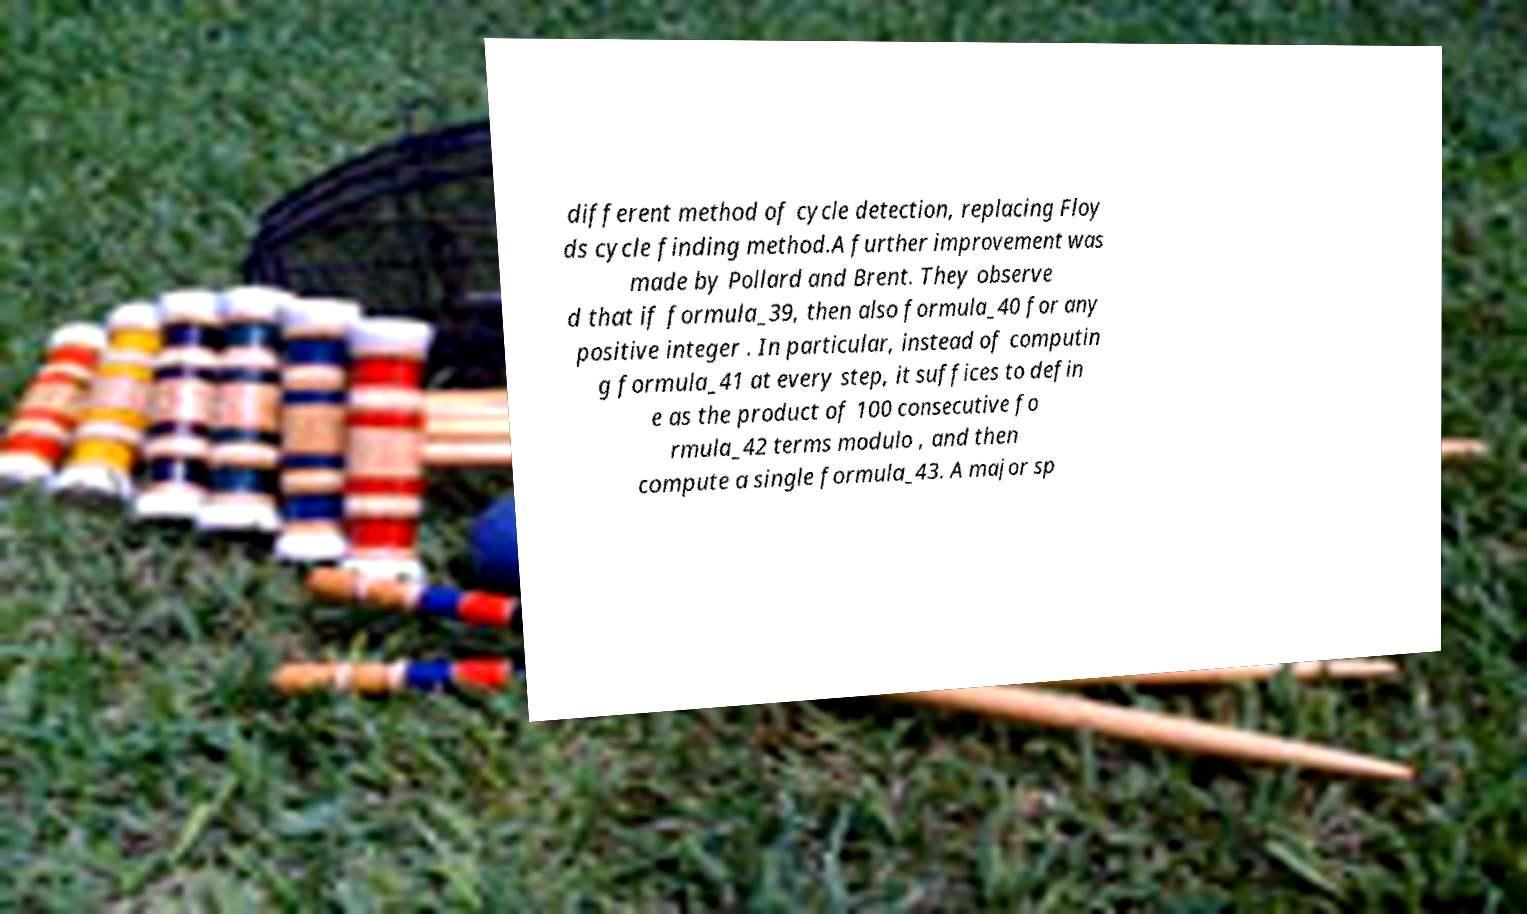Could you assist in decoding the text presented in this image and type it out clearly? different method of cycle detection, replacing Floy ds cycle finding method.A further improvement was made by Pollard and Brent. They observe d that if formula_39, then also formula_40 for any positive integer . In particular, instead of computin g formula_41 at every step, it suffices to defin e as the product of 100 consecutive fo rmula_42 terms modulo , and then compute a single formula_43. A major sp 